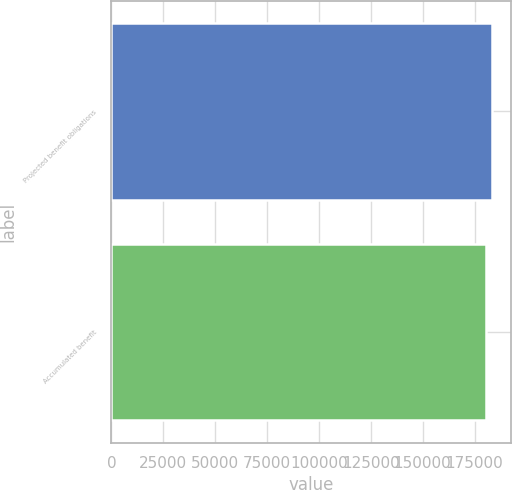Convert chart to OTSL. <chart><loc_0><loc_0><loc_500><loc_500><bar_chart><fcel>Projected benefit obligations<fcel>Accumulated benefit<nl><fcel>183424<fcel>180560<nl></chart> 